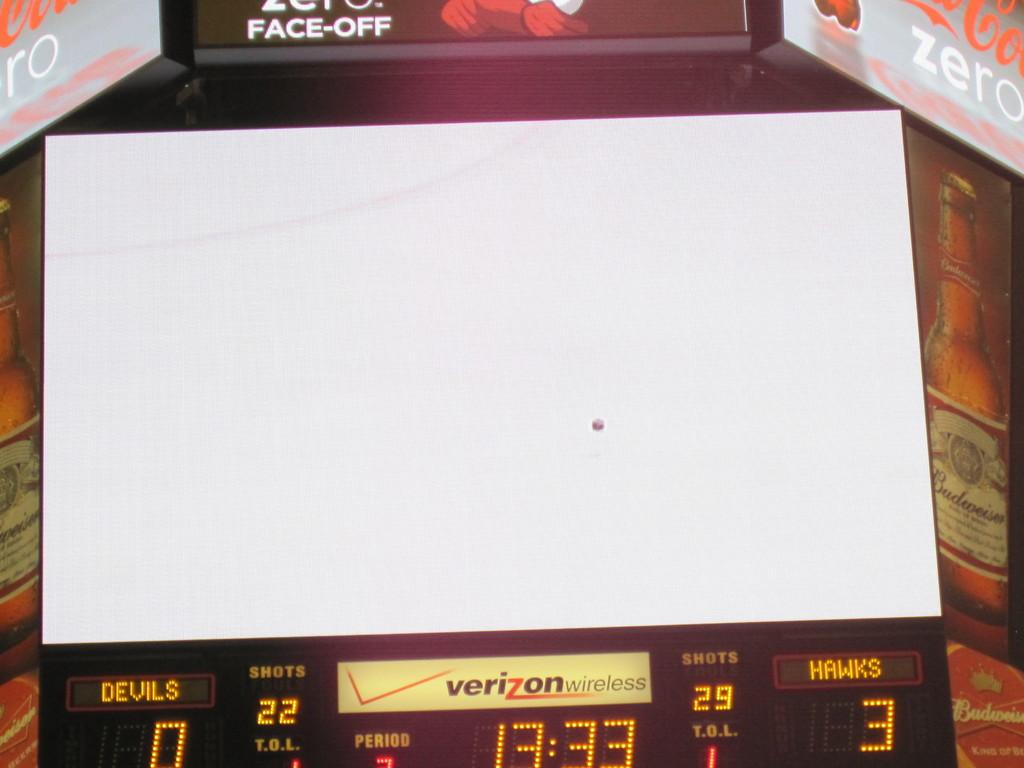<image>
Provide a brief description of the given image. a timeclock for a basketball game at 13:33 